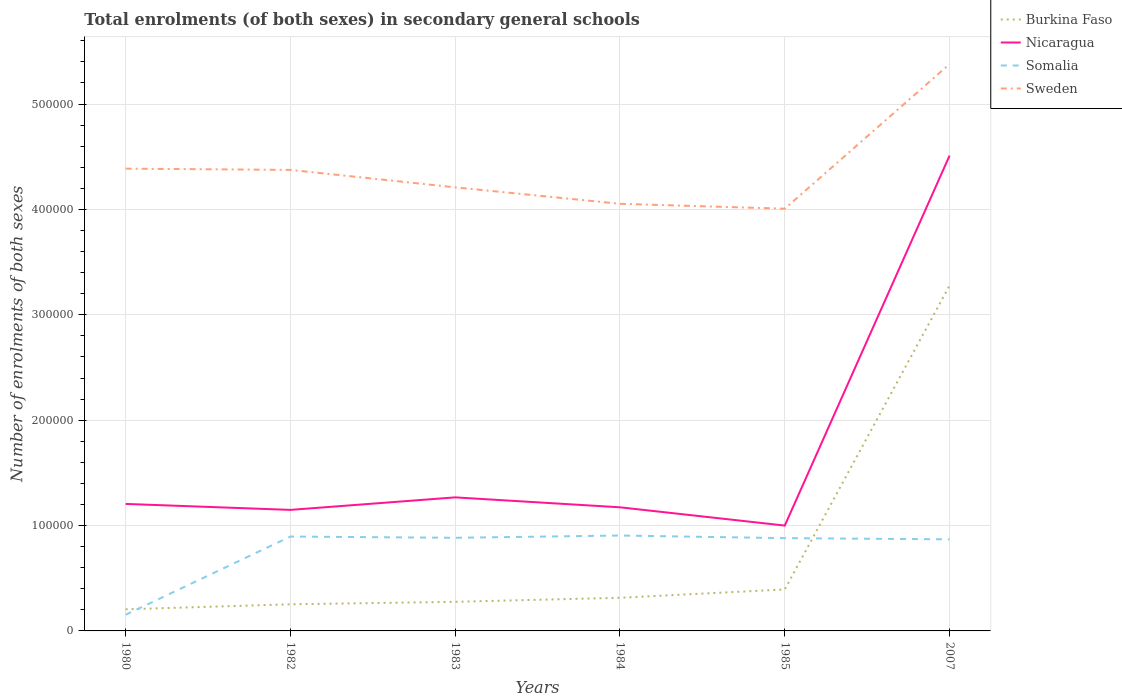Across all years, what is the maximum number of enrolments in secondary schools in Somalia?
Give a very brief answer. 1.53e+04. In which year was the number of enrolments in secondary schools in Nicaragua maximum?
Your answer should be compact. 1985. What is the total number of enrolments in secondary schools in Sweden in the graph?
Ensure brevity in your answer.  1.65e+04. What is the difference between the highest and the second highest number of enrolments in secondary schools in Burkina Faso?
Offer a terse response. 3.07e+05. What is the difference between the highest and the lowest number of enrolments in secondary schools in Sweden?
Keep it short and to the point. 1. Is the number of enrolments in secondary schools in Somalia strictly greater than the number of enrolments in secondary schools in Burkina Faso over the years?
Offer a very short reply. No. What is the difference between two consecutive major ticks on the Y-axis?
Your response must be concise. 1.00e+05. Does the graph contain any zero values?
Your answer should be compact. No. Does the graph contain grids?
Your answer should be compact. Yes. How many legend labels are there?
Ensure brevity in your answer.  4. How are the legend labels stacked?
Ensure brevity in your answer.  Vertical. What is the title of the graph?
Ensure brevity in your answer.  Total enrolments (of both sexes) in secondary general schools. What is the label or title of the Y-axis?
Your response must be concise. Number of enrolments of both sexes. What is the Number of enrolments of both sexes in Burkina Faso in 1980?
Keep it short and to the point. 2.05e+04. What is the Number of enrolments of both sexes of Nicaragua in 1980?
Keep it short and to the point. 1.21e+05. What is the Number of enrolments of both sexes in Somalia in 1980?
Ensure brevity in your answer.  1.53e+04. What is the Number of enrolments of both sexes in Sweden in 1980?
Provide a succinct answer. 4.39e+05. What is the Number of enrolments of both sexes of Burkina Faso in 1982?
Offer a terse response. 2.53e+04. What is the Number of enrolments of both sexes of Nicaragua in 1982?
Give a very brief answer. 1.15e+05. What is the Number of enrolments of both sexes of Somalia in 1982?
Offer a terse response. 8.96e+04. What is the Number of enrolments of both sexes of Sweden in 1982?
Ensure brevity in your answer.  4.38e+05. What is the Number of enrolments of both sexes of Burkina Faso in 1983?
Offer a very short reply. 2.76e+04. What is the Number of enrolments of both sexes of Nicaragua in 1983?
Ensure brevity in your answer.  1.27e+05. What is the Number of enrolments of both sexes in Somalia in 1983?
Offer a terse response. 8.84e+04. What is the Number of enrolments of both sexes in Sweden in 1983?
Your answer should be very brief. 4.21e+05. What is the Number of enrolments of both sexes of Burkina Faso in 1984?
Keep it short and to the point. 3.15e+04. What is the Number of enrolments of both sexes of Nicaragua in 1984?
Offer a very short reply. 1.17e+05. What is the Number of enrolments of both sexes in Somalia in 1984?
Your response must be concise. 9.05e+04. What is the Number of enrolments of both sexes in Sweden in 1984?
Offer a very short reply. 4.05e+05. What is the Number of enrolments of both sexes in Burkina Faso in 1985?
Offer a terse response. 3.94e+04. What is the Number of enrolments of both sexes of Nicaragua in 1985?
Your answer should be very brief. 1.00e+05. What is the Number of enrolments of both sexes of Somalia in 1985?
Your answer should be very brief. 8.80e+04. What is the Number of enrolments of both sexes of Sweden in 1985?
Ensure brevity in your answer.  4.01e+05. What is the Number of enrolments of both sexes in Burkina Faso in 2007?
Offer a very short reply. 3.28e+05. What is the Number of enrolments of both sexes in Nicaragua in 2007?
Provide a succinct answer. 4.51e+05. What is the Number of enrolments of both sexes in Somalia in 2007?
Keep it short and to the point. 8.69e+04. What is the Number of enrolments of both sexes of Sweden in 2007?
Give a very brief answer. 5.38e+05. Across all years, what is the maximum Number of enrolments of both sexes of Burkina Faso?
Provide a short and direct response. 3.28e+05. Across all years, what is the maximum Number of enrolments of both sexes of Nicaragua?
Offer a terse response. 4.51e+05. Across all years, what is the maximum Number of enrolments of both sexes in Somalia?
Make the answer very short. 9.05e+04. Across all years, what is the maximum Number of enrolments of both sexes of Sweden?
Provide a succinct answer. 5.38e+05. Across all years, what is the minimum Number of enrolments of both sexes in Burkina Faso?
Make the answer very short. 2.05e+04. Across all years, what is the minimum Number of enrolments of both sexes of Nicaragua?
Your answer should be compact. 1.00e+05. Across all years, what is the minimum Number of enrolments of both sexes in Somalia?
Provide a short and direct response. 1.53e+04. Across all years, what is the minimum Number of enrolments of both sexes of Sweden?
Your answer should be compact. 4.01e+05. What is the total Number of enrolments of both sexes in Burkina Faso in the graph?
Make the answer very short. 4.72e+05. What is the total Number of enrolments of both sexes of Nicaragua in the graph?
Ensure brevity in your answer.  1.03e+06. What is the total Number of enrolments of both sexes of Somalia in the graph?
Make the answer very short. 4.59e+05. What is the total Number of enrolments of both sexes of Sweden in the graph?
Ensure brevity in your answer.  2.64e+06. What is the difference between the Number of enrolments of both sexes in Burkina Faso in 1980 and that in 1982?
Make the answer very short. -4744. What is the difference between the Number of enrolments of both sexes in Nicaragua in 1980 and that in 1982?
Keep it short and to the point. 5654. What is the difference between the Number of enrolments of both sexes of Somalia in 1980 and that in 1982?
Offer a very short reply. -7.42e+04. What is the difference between the Number of enrolments of both sexes of Sweden in 1980 and that in 1982?
Provide a short and direct response. 1194. What is the difference between the Number of enrolments of both sexes of Burkina Faso in 1980 and that in 1983?
Give a very brief answer. -7089. What is the difference between the Number of enrolments of both sexes in Nicaragua in 1980 and that in 1983?
Provide a succinct answer. -6216. What is the difference between the Number of enrolments of both sexes of Somalia in 1980 and that in 1983?
Give a very brief answer. -7.30e+04. What is the difference between the Number of enrolments of both sexes of Sweden in 1980 and that in 1983?
Offer a terse response. 1.77e+04. What is the difference between the Number of enrolments of both sexes in Burkina Faso in 1980 and that in 1984?
Give a very brief answer. -1.09e+04. What is the difference between the Number of enrolments of both sexes of Nicaragua in 1980 and that in 1984?
Offer a terse response. 3207. What is the difference between the Number of enrolments of both sexes of Somalia in 1980 and that in 1984?
Your response must be concise. -7.52e+04. What is the difference between the Number of enrolments of both sexes of Sweden in 1980 and that in 1984?
Your response must be concise. 3.34e+04. What is the difference between the Number of enrolments of both sexes in Burkina Faso in 1980 and that in 1985?
Provide a short and direct response. -1.88e+04. What is the difference between the Number of enrolments of both sexes in Nicaragua in 1980 and that in 1985?
Ensure brevity in your answer.  2.05e+04. What is the difference between the Number of enrolments of both sexes in Somalia in 1980 and that in 1985?
Ensure brevity in your answer.  -7.27e+04. What is the difference between the Number of enrolments of both sexes in Sweden in 1980 and that in 1985?
Provide a succinct answer. 3.80e+04. What is the difference between the Number of enrolments of both sexes of Burkina Faso in 1980 and that in 2007?
Ensure brevity in your answer.  -3.07e+05. What is the difference between the Number of enrolments of both sexes of Nicaragua in 1980 and that in 2007?
Keep it short and to the point. -3.31e+05. What is the difference between the Number of enrolments of both sexes of Somalia in 1980 and that in 2007?
Your answer should be compact. -7.16e+04. What is the difference between the Number of enrolments of both sexes in Sweden in 1980 and that in 2007?
Provide a short and direct response. -9.92e+04. What is the difference between the Number of enrolments of both sexes of Burkina Faso in 1982 and that in 1983?
Offer a very short reply. -2345. What is the difference between the Number of enrolments of both sexes of Nicaragua in 1982 and that in 1983?
Provide a succinct answer. -1.19e+04. What is the difference between the Number of enrolments of both sexes of Somalia in 1982 and that in 1983?
Your response must be concise. 1177. What is the difference between the Number of enrolments of both sexes of Sweden in 1982 and that in 1983?
Provide a short and direct response. 1.65e+04. What is the difference between the Number of enrolments of both sexes in Burkina Faso in 1982 and that in 1984?
Provide a short and direct response. -6201. What is the difference between the Number of enrolments of both sexes in Nicaragua in 1982 and that in 1984?
Your answer should be very brief. -2447. What is the difference between the Number of enrolments of both sexes of Somalia in 1982 and that in 1984?
Offer a very short reply. -977. What is the difference between the Number of enrolments of both sexes of Sweden in 1982 and that in 1984?
Your answer should be very brief. 3.22e+04. What is the difference between the Number of enrolments of both sexes of Burkina Faso in 1982 and that in 1985?
Your response must be concise. -1.41e+04. What is the difference between the Number of enrolments of both sexes in Nicaragua in 1982 and that in 1985?
Give a very brief answer. 1.49e+04. What is the difference between the Number of enrolments of both sexes in Somalia in 1982 and that in 1985?
Offer a terse response. 1519. What is the difference between the Number of enrolments of both sexes in Sweden in 1982 and that in 1985?
Your answer should be very brief. 3.68e+04. What is the difference between the Number of enrolments of both sexes of Burkina Faso in 1982 and that in 2007?
Offer a terse response. -3.03e+05. What is the difference between the Number of enrolments of both sexes in Nicaragua in 1982 and that in 2007?
Keep it short and to the point. -3.36e+05. What is the difference between the Number of enrolments of both sexes of Somalia in 1982 and that in 2007?
Ensure brevity in your answer.  2629. What is the difference between the Number of enrolments of both sexes in Sweden in 1982 and that in 2007?
Provide a short and direct response. -1.00e+05. What is the difference between the Number of enrolments of both sexes in Burkina Faso in 1983 and that in 1984?
Provide a succinct answer. -3856. What is the difference between the Number of enrolments of both sexes of Nicaragua in 1983 and that in 1984?
Your answer should be very brief. 9423. What is the difference between the Number of enrolments of both sexes of Somalia in 1983 and that in 1984?
Keep it short and to the point. -2154. What is the difference between the Number of enrolments of both sexes of Sweden in 1983 and that in 1984?
Give a very brief answer. 1.56e+04. What is the difference between the Number of enrolments of both sexes of Burkina Faso in 1983 and that in 1985?
Ensure brevity in your answer.  -1.18e+04. What is the difference between the Number of enrolments of both sexes of Nicaragua in 1983 and that in 1985?
Offer a very short reply. 2.68e+04. What is the difference between the Number of enrolments of both sexes of Somalia in 1983 and that in 1985?
Give a very brief answer. 342. What is the difference between the Number of enrolments of both sexes in Sweden in 1983 and that in 1985?
Offer a very short reply. 2.03e+04. What is the difference between the Number of enrolments of both sexes of Burkina Faso in 1983 and that in 2007?
Offer a very short reply. -3.00e+05. What is the difference between the Number of enrolments of both sexes of Nicaragua in 1983 and that in 2007?
Provide a succinct answer. -3.24e+05. What is the difference between the Number of enrolments of both sexes of Somalia in 1983 and that in 2007?
Offer a terse response. 1452. What is the difference between the Number of enrolments of both sexes of Sweden in 1983 and that in 2007?
Your response must be concise. -1.17e+05. What is the difference between the Number of enrolments of both sexes of Burkina Faso in 1984 and that in 1985?
Offer a terse response. -7895. What is the difference between the Number of enrolments of both sexes of Nicaragua in 1984 and that in 1985?
Give a very brief answer. 1.73e+04. What is the difference between the Number of enrolments of both sexes of Somalia in 1984 and that in 1985?
Your answer should be compact. 2496. What is the difference between the Number of enrolments of both sexes of Sweden in 1984 and that in 1985?
Your answer should be compact. 4644. What is the difference between the Number of enrolments of both sexes in Burkina Faso in 1984 and that in 2007?
Your answer should be compact. -2.96e+05. What is the difference between the Number of enrolments of both sexes of Nicaragua in 1984 and that in 2007?
Your answer should be compact. -3.34e+05. What is the difference between the Number of enrolments of both sexes of Somalia in 1984 and that in 2007?
Give a very brief answer. 3606. What is the difference between the Number of enrolments of both sexes in Sweden in 1984 and that in 2007?
Keep it short and to the point. -1.33e+05. What is the difference between the Number of enrolments of both sexes of Burkina Faso in 1985 and that in 2007?
Your answer should be very brief. -2.88e+05. What is the difference between the Number of enrolments of both sexes in Nicaragua in 1985 and that in 2007?
Give a very brief answer. -3.51e+05. What is the difference between the Number of enrolments of both sexes in Somalia in 1985 and that in 2007?
Your response must be concise. 1110. What is the difference between the Number of enrolments of both sexes in Sweden in 1985 and that in 2007?
Your answer should be very brief. -1.37e+05. What is the difference between the Number of enrolments of both sexes in Burkina Faso in 1980 and the Number of enrolments of both sexes in Nicaragua in 1982?
Ensure brevity in your answer.  -9.43e+04. What is the difference between the Number of enrolments of both sexes in Burkina Faso in 1980 and the Number of enrolments of both sexes in Somalia in 1982?
Provide a short and direct response. -6.90e+04. What is the difference between the Number of enrolments of both sexes in Burkina Faso in 1980 and the Number of enrolments of both sexes in Sweden in 1982?
Your answer should be very brief. -4.17e+05. What is the difference between the Number of enrolments of both sexes in Nicaragua in 1980 and the Number of enrolments of both sexes in Somalia in 1982?
Ensure brevity in your answer.  3.10e+04. What is the difference between the Number of enrolments of both sexes in Nicaragua in 1980 and the Number of enrolments of both sexes in Sweden in 1982?
Ensure brevity in your answer.  -3.17e+05. What is the difference between the Number of enrolments of both sexes of Somalia in 1980 and the Number of enrolments of both sexes of Sweden in 1982?
Give a very brief answer. -4.22e+05. What is the difference between the Number of enrolments of both sexes of Burkina Faso in 1980 and the Number of enrolments of both sexes of Nicaragua in 1983?
Offer a terse response. -1.06e+05. What is the difference between the Number of enrolments of both sexes in Burkina Faso in 1980 and the Number of enrolments of both sexes in Somalia in 1983?
Your answer should be compact. -6.79e+04. What is the difference between the Number of enrolments of both sexes of Burkina Faso in 1980 and the Number of enrolments of both sexes of Sweden in 1983?
Your response must be concise. -4.00e+05. What is the difference between the Number of enrolments of both sexes in Nicaragua in 1980 and the Number of enrolments of both sexes in Somalia in 1983?
Ensure brevity in your answer.  3.21e+04. What is the difference between the Number of enrolments of both sexes in Nicaragua in 1980 and the Number of enrolments of both sexes in Sweden in 1983?
Ensure brevity in your answer.  -3.00e+05. What is the difference between the Number of enrolments of both sexes in Somalia in 1980 and the Number of enrolments of both sexes in Sweden in 1983?
Make the answer very short. -4.06e+05. What is the difference between the Number of enrolments of both sexes of Burkina Faso in 1980 and the Number of enrolments of both sexes of Nicaragua in 1984?
Offer a very short reply. -9.68e+04. What is the difference between the Number of enrolments of both sexes in Burkina Faso in 1980 and the Number of enrolments of both sexes in Somalia in 1984?
Offer a very short reply. -7.00e+04. What is the difference between the Number of enrolments of both sexes in Burkina Faso in 1980 and the Number of enrolments of both sexes in Sweden in 1984?
Make the answer very short. -3.85e+05. What is the difference between the Number of enrolments of both sexes of Nicaragua in 1980 and the Number of enrolments of both sexes of Somalia in 1984?
Provide a succinct answer. 3.00e+04. What is the difference between the Number of enrolments of both sexes of Nicaragua in 1980 and the Number of enrolments of both sexes of Sweden in 1984?
Provide a short and direct response. -2.85e+05. What is the difference between the Number of enrolments of both sexes of Somalia in 1980 and the Number of enrolments of both sexes of Sweden in 1984?
Offer a terse response. -3.90e+05. What is the difference between the Number of enrolments of both sexes of Burkina Faso in 1980 and the Number of enrolments of both sexes of Nicaragua in 1985?
Ensure brevity in your answer.  -7.95e+04. What is the difference between the Number of enrolments of both sexes in Burkina Faso in 1980 and the Number of enrolments of both sexes in Somalia in 1985?
Provide a short and direct response. -6.75e+04. What is the difference between the Number of enrolments of both sexes in Burkina Faso in 1980 and the Number of enrolments of both sexes in Sweden in 1985?
Ensure brevity in your answer.  -3.80e+05. What is the difference between the Number of enrolments of both sexes in Nicaragua in 1980 and the Number of enrolments of both sexes in Somalia in 1985?
Give a very brief answer. 3.25e+04. What is the difference between the Number of enrolments of both sexes in Nicaragua in 1980 and the Number of enrolments of both sexes in Sweden in 1985?
Give a very brief answer. -2.80e+05. What is the difference between the Number of enrolments of both sexes in Somalia in 1980 and the Number of enrolments of both sexes in Sweden in 1985?
Provide a succinct answer. -3.85e+05. What is the difference between the Number of enrolments of both sexes of Burkina Faso in 1980 and the Number of enrolments of both sexes of Nicaragua in 2007?
Ensure brevity in your answer.  -4.31e+05. What is the difference between the Number of enrolments of both sexes in Burkina Faso in 1980 and the Number of enrolments of both sexes in Somalia in 2007?
Your answer should be very brief. -6.64e+04. What is the difference between the Number of enrolments of both sexes in Burkina Faso in 1980 and the Number of enrolments of both sexes in Sweden in 2007?
Your response must be concise. -5.17e+05. What is the difference between the Number of enrolments of both sexes in Nicaragua in 1980 and the Number of enrolments of both sexes in Somalia in 2007?
Make the answer very short. 3.36e+04. What is the difference between the Number of enrolments of both sexes in Nicaragua in 1980 and the Number of enrolments of both sexes in Sweden in 2007?
Provide a succinct answer. -4.17e+05. What is the difference between the Number of enrolments of both sexes of Somalia in 1980 and the Number of enrolments of both sexes of Sweden in 2007?
Your response must be concise. -5.23e+05. What is the difference between the Number of enrolments of both sexes of Burkina Faso in 1982 and the Number of enrolments of both sexes of Nicaragua in 1983?
Your response must be concise. -1.01e+05. What is the difference between the Number of enrolments of both sexes of Burkina Faso in 1982 and the Number of enrolments of both sexes of Somalia in 1983?
Provide a short and direct response. -6.31e+04. What is the difference between the Number of enrolments of both sexes in Burkina Faso in 1982 and the Number of enrolments of both sexes in Sweden in 1983?
Your answer should be very brief. -3.96e+05. What is the difference between the Number of enrolments of both sexes of Nicaragua in 1982 and the Number of enrolments of both sexes of Somalia in 1983?
Keep it short and to the point. 2.65e+04. What is the difference between the Number of enrolments of both sexes in Nicaragua in 1982 and the Number of enrolments of both sexes in Sweden in 1983?
Give a very brief answer. -3.06e+05. What is the difference between the Number of enrolments of both sexes of Somalia in 1982 and the Number of enrolments of both sexes of Sweden in 1983?
Provide a succinct answer. -3.31e+05. What is the difference between the Number of enrolments of both sexes in Burkina Faso in 1982 and the Number of enrolments of both sexes in Nicaragua in 1984?
Your answer should be very brief. -9.20e+04. What is the difference between the Number of enrolments of both sexes of Burkina Faso in 1982 and the Number of enrolments of both sexes of Somalia in 1984?
Make the answer very short. -6.53e+04. What is the difference between the Number of enrolments of both sexes in Burkina Faso in 1982 and the Number of enrolments of both sexes in Sweden in 1984?
Your answer should be compact. -3.80e+05. What is the difference between the Number of enrolments of both sexes in Nicaragua in 1982 and the Number of enrolments of both sexes in Somalia in 1984?
Offer a very short reply. 2.43e+04. What is the difference between the Number of enrolments of both sexes of Nicaragua in 1982 and the Number of enrolments of both sexes of Sweden in 1984?
Make the answer very short. -2.90e+05. What is the difference between the Number of enrolments of both sexes in Somalia in 1982 and the Number of enrolments of both sexes in Sweden in 1984?
Your answer should be compact. -3.16e+05. What is the difference between the Number of enrolments of both sexes of Burkina Faso in 1982 and the Number of enrolments of both sexes of Nicaragua in 1985?
Your response must be concise. -7.47e+04. What is the difference between the Number of enrolments of both sexes in Burkina Faso in 1982 and the Number of enrolments of both sexes in Somalia in 1985?
Keep it short and to the point. -6.28e+04. What is the difference between the Number of enrolments of both sexes in Burkina Faso in 1982 and the Number of enrolments of both sexes in Sweden in 1985?
Offer a very short reply. -3.75e+05. What is the difference between the Number of enrolments of both sexes of Nicaragua in 1982 and the Number of enrolments of both sexes of Somalia in 1985?
Give a very brief answer. 2.68e+04. What is the difference between the Number of enrolments of both sexes in Nicaragua in 1982 and the Number of enrolments of both sexes in Sweden in 1985?
Keep it short and to the point. -2.86e+05. What is the difference between the Number of enrolments of both sexes in Somalia in 1982 and the Number of enrolments of both sexes in Sweden in 1985?
Keep it short and to the point. -3.11e+05. What is the difference between the Number of enrolments of both sexes of Burkina Faso in 1982 and the Number of enrolments of both sexes of Nicaragua in 2007?
Give a very brief answer. -4.26e+05. What is the difference between the Number of enrolments of both sexes of Burkina Faso in 1982 and the Number of enrolments of both sexes of Somalia in 2007?
Provide a succinct answer. -6.17e+04. What is the difference between the Number of enrolments of both sexes in Burkina Faso in 1982 and the Number of enrolments of both sexes in Sweden in 2007?
Ensure brevity in your answer.  -5.13e+05. What is the difference between the Number of enrolments of both sexes of Nicaragua in 1982 and the Number of enrolments of both sexes of Somalia in 2007?
Your answer should be compact. 2.79e+04. What is the difference between the Number of enrolments of both sexes in Nicaragua in 1982 and the Number of enrolments of both sexes in Sweden in 2007?
Keep it short and to the point. -4.23e+05. What is the difference between the Number of enrolments of both sexes of Somalia in 1982 and the Number of enrolments of both sexes of Sweden in 2007?
Keep it short and to the point. -4.48e+05. What is the difference between the Number of enrolments of both sexes in Burkina Faso in 1983 and the Number of enrolments of both sexes in Nicaragua in 1984?
Give a very brief answer. -8.97e+04. What is the difference between the Number of enrolments of both sexes in Burkina Faso in 1983 and the Number of enrolments of both sexes in Somalia in 1984?
Your answer should be compact. -6.29e+04. What is the difference between the Number of enrolments of both sexes in Burkina Faso in 1983 and the Number of enrolments of both sexes in Sweden in 1984?
Give a very brief answer. -3.78e+05. What is the difference between the Number of enrolments of both sexes of Nicaragua in 1983 and the Number of enrolments of both sexes of Somalia in 1984?
Offer a terse response. 3.62e+04. What is the difference between the Number of enrolments of both sexes in Nicaragua in 1983 and the Number of enrolments of both sexes in Sweden in 1984?
Provide a succinct answer. -2.79e+05. What is the difference between the Number of enrolments of both sexes in Somalia in 1983 and the Number of enrolments of both sexes in Sweden in 1984?
Make the answer very short. -3.17e+05. What is the difference between the Number of enrolments of both sexes of Burkina Faso in 1983 and the Number of enrolments of both sexes of Nicaragua in 1985?
Your answer should be very brief. -7.24e+04. What is the difference between the Number of enrolments of both sexes of Burkina Faso in 1983 and the Number of enrolments of both sexes of Somalia in 1985?
Offer a terse response. -6.04e+04. What is the difference between the Number of enrolments of both sexes in Burkina Faso in 1983 and the Number of enrolments of both sexes in Sweden in 1985?
Make the answer very short. -3.73e+05. What is the difference between the Number of enrolments of both sexes in Nicaragua in 1983 and the Number of enrolments of both sexes in Somalia in 1985?
Give a very brief answer. 3.87e+04. What is the difference between the Number of enrolments of both sexes in Nicaragua in 1983 and the Number of enrolments of both sexes in Sweden in 1985?
Ensure brevity in your answer.  -2.74e+05. What is the difference between the Number of enrolments of both sexes of Somalia in 1983 and the Number of enrolments of both sexes of Sweden in 1985?
Offer a very short reply. -3.12e+05. What is the difference between the Number of enrolments of both sexes in Burkina Faso in 1983 and the Number of enrolments of both sexes in Nicaragua in 2007?
Offer a terse response. -4.23e+05. What is the difference between the Number of enrolments of both sexes in Burkina Faso in 1983 and the Number of enrolments of both sexes in Somalia in 2007?
Your response must be concise. -5.93e+04. What is the difference between the Number of enrolments of both sexes in Burkina Faso in 1983 and the Number of enrolments of both sexes in Sweden in 2007?
Provide a short and direct response. -5.10e+05. What is the difference between the Number of enrolments of both sexes in Nicaragua in 1983 and the Number of enrolments of both sexes in Somalia in 2007?
Your answer should be very brief. 3.98e+04. What is the difference between the Number of enrolments of both sexes of Nicaragua in 1983 and the Number of enrolments of both sexes of Sweden in 2007?
Offer a very short reply. -4.11e+05. What is the difference between the Number of enrolments of both sexes in Somalia in 1983 and the Number of enrolments of both sexes in Sweden in 2007?
Make the answer very short. -4.50e+05. What is the difference between the Number of enrolments of both sexes in Burkina Faso in 1984 and the Number of enrolments of both sexes in Nicaragua in 1985?
Offer a terse response. -6.85e+04. What is the difference between the Number of enrolments of both sexes in Burkina Faso in 1984 and the Number of enrolments of both sexes in Somalia in 1985?
Provide a short and direct response. -5.66e+04. What is the difference between the Number of enrolments of both sexes of Burkina Faso in 1984 and the Number of enrolments of both sexes of Sweden in 1985?
Offer a very short reply. -3.69e+05. What is the difference between the Number of enrolments of both sexes of Nicaragua in 1984 and the Number of enrolments of both sexes of Somalia in 1985?
Your answer should be very brief. 2.93e+04. What is the difference between the Number of enrolments of both sexes of Nicaragua in 1984 and the Number of enrolments of both sexes of Sweden in 1985?
Provide a short and direct response. -2.83e+05. What is the difference between the Number of enrolments of both sexes in Somalia in 1984 and the Number of enrolments of both sexes in Sweden in 1985?
Offer a terse response. -3.10e+05. What is the difference between the Number of enrolments of both sexes of Burkina Faso in 1984 and the Number of enrolments of both sexes of Nicaragua in 2007?
Your answer should be very brief. -4.20e+05. What is the difference between the Number of enrolments of both sexes in Burkina Faso in 1984 and the Number of enrolments of both sexes in Somalia in 2007?
Your response must be concise. -5.55e+04. What is the difference between the Number of enrolments of both sexes in Burkina Faso in 1984 and the Number of enrolments of both sexes in Sweden in 2007?
Provide a succinct answer. -5.06e+05. What is the difference between the Number of enrolments of both sexes in Nicaragua in 1984 and the Number of enrolments of both sexes in Somalia in 2007?
Your answer should be very brief. 3.04e+04. What is the difference between the Number of enrolments of both sexes of Nicaragua in 1984 and the Number of enrolments of both sexes of Sweden in 2007?
Give a very brief answer. -4.21e+05. What is the difference between the Number of enrolments of both sexes in Somalia in 1984 and the Number of enrolments of both sexes in Sweden in 2007?
Keep it short and to the point. -4.47e+05. What is the difference between the Number of enrolments of both sexes of Burkina Faso in 1985 and the Number of enrolments of both sexes of Nicaragua in 2007?
Provide a short and direct response. -4.12e+05. What is the difference between the Number of enrolments of both sexes in Burkina Faso in 1985 and the Number of enrolments of both sexes in Somalia in 2007?
Provide a succinct answer. -4.76e+04. What is the difference between the Number of enrolments of both sexes in Burkina Faso in 1985 and the Number of enrolments of both sexes in Sweden in 2007?
Offer a terse response. -4.99e+05. What is the difference between the Number of enrolments of both sexes of Nicaragua in 1985 and the Number of enrolments of both sexes of Somalia in 2007?
Your answer should be very brief. 1.31e+04. What is the difference between the Number of enrolments of both sexes of Nicaragua in 1985 and the Number of enrolments of both sexes of Sweden in 2007?
Your answer should be very brief. -4.38e+05. What is the difference between the Number of enrolments of both sexes in Somalia in 1985 and the Number of enrolments of both sexes in Sweden in 2007?
Give a very brief answer. -4.50e+05. What is the average Number of enrolments of both sexes of Burkina Faso per year?
Your response must be concise. 7.87e+04. What is the average Number of enrolments of both sexes of Nicaragua per year?
Keep it short and to the point. 1.72e+05. What is the average Number of enrolments of both sexes in Somalia per year?
Provide a succinct answer. 7.65e+04. What is the average Number of enrolments of both sexes in Sweden per year?
Your response must be concise. 4.40e+05. In the year 1980, what is the difference between the Number of enrolments of both sexes in Burkina Faso and Number of enrolments of both sexes in Nicaragua?
Offer a very short reply. -1.00e+05. In the year 1980, what is the difference between the Number of enrolments of both sexes in Burkina Faso and Number of enrolments of both sexes in Somalia?
Give a very brief answer. 5191. In the year 1980, what is the difference between the Number of enrolments of both sexes in Burkina Faso and Number of enrolments of both sexes in Sweden?
Ensure brevity in your answer.  -4.18e+05. In the year 1980, what is the difference between the Number of enrolments of both sexes of Nicaragua and Number of enrolments of both sexes of Somalia?
Keep it short and to the point. 1.05e+05. In the year 1980, what is the difference between the Number of enrolments of both sexes of Nicaragua and Number of enrolments of both sexes of Sweden?
Provide a short and direct response. -3.18e+05. In the year 1980, what is the difference between the Number of enrolments of both sexes of Somalia and Number of enrolments of both sexes of Sweden?
Your response must be concise. -4.23e+05. In the year 1982, what is the difference between the Number of enrolments of both sexes of Burkina Faso and Number of enrolments of both sexes of Nicaragua?
Your response must be concise. -8.96e+04. In the year 1982, what is the difference between the Number of enrolments of both sexes in Burkina Faso and Number of enrolments of both sexes in Somalia?
Make the answer very short. -6.43e+04. In the year 1982, what is the difference between the Number of enrolments of both sexes of Burkina Faso and Number of enrolments of both sexes of Sweden?
Keep it short and to the point. -4.12e+05. In the year 1982, what is the difference between the Number of enrolments of both sexes of Nicaragua and Number of enrolments of both sexes of Somalia?
Provide a succinct answer. 2.53e+04. In the year 1982, what is the difference between the Number of enrolments of both sexes of Nicaragua and Number of enrolments of both sexes of Sweden?
Keep it short and to the point. -3.23e+05. In the year 1982, what is the difference between the Number of enrolments of both sexes in Somalia and Number of enrolments of both sexes in Sweden?
Give a very brief answer. -3.48e+05. In the year 1983, what is the difference between the Number of enrolments of both sexes of Burkina Faso and Number of enrolments of both sexes of Nicaragua?
Ensure brevity in your answer.  -9.91e+04. In the year 1983, what is the difference between the Number of enrolments of both sexes of Burkina Faso and Number of enrolments of both sexes of Somalia?
Provide a succinct answer. -6.08e+04. In the year 1983, what is the difference between the Number of enrolments of both sexes of Burkina Faso and Number of enrolments of both sexes of Sweden?
Your answer should be very brief. -3.93e+05. In the year 1983, what is the difference between the Number of enrolments of both sexes in Nicaragua and Number of enrolments of both sexes in Somalia?
Offer a very short reply. 3.84e+04. In the year 1983, what is the difference between the Number of enrolments of both sexes of Nicaragua and Number of enrolments of both sexes of Sweden?
Offer a terse response. -2.94e+05. In the year 1983, what is the difference between the Number of enrolments of both sexes of Somalia and Number of enrolments of both sexes of Sweden?
Offer a terse response. -3.33e+05. In the year 1984, what is the difference between the Number of enrolments of both sexes of Burkina Faso and Number of enrolments of both sexes of Nicaragua?
Your response must be concise. -8.58e+04. In the year 1984, what is the difference between the Number of enrolments of both sexes of Burkina Faso and Number of enrolments of both sexes of Somalia?
Give a very brief answer. -5.91e+04. In the year 1984, what is the difference between the Number of enrolments of both sexes in Burkina Faso and Number of enrolments of both sexes in Sweden?
Offer a very short reply. -3.74e+05. In the year 1984, what is the difference between the Number of enrolments of both sexes of Nicaragua and Number of enrolments of both sexes of Somalia?
Keep it short and to the point. 2.68e+04. In the year 1984, what is the difference between the Number of enrolments of both sexes of Nicaragua and Number of enrolments of both sexes of Sweden?
Your response must be concise. -2.88e+05. In the year 1984, what is the difference between the Number of enrolments of both sexes of Somalia and Number of enrolments of both sexes of Sweden?
Your response must be concise. -3.15e+05. In the year 1985, what is the difference between the Number of enrolments of both sexes in Burkina Faso and Number of enrolments of both sexes in Nicaragua?
Ensure brevity in your answer.  -6.06e+04. In the year 1985, what is the difference between the Number of enrolments of both sexes of Burkina Faso and Number of enrolments of both sexes of Somalia?
Ensure brevity in your answer.  -4.87e+04. In the year 1985, what is the difference between the Number of enrolments of both sexes of Burkina Faso and Number of enrolments of both sexes of Sweden?
Provide a short and direct response. -3.61e+05. In the year 1985, what is the difference between the Number of enrolments of both sexes of Nicaragua and Number of enrolments of both sexes of Somalia?
Keep it short and to the point. 1.19e+04. In the year 1985, what is the difference between the Number of enrolments of both sexes of Nicaragua and Number of enrolments of both sexes of Sweden?
Your answer should be compact. -3.01e+05. In the year 1985, what is the difference between the Number of enrolments of both sexes in Somalia and Number of enrolments of both sexes in Sweden?
Provide a short and direct response. -3.13e+05. In the year 2007, what is the difference between the Number of enrolments of both sexes of Burkina Faso and Number of enrolments of both sexes of Nicaragua?
Your answer should be very brief. -1.23e+05. In the year 2007, what is the difference between the Number of enrolments of both sexes of Burkina Faso and Number of enrolments of both sexes of Somalia?
Make the answer very short. 2.41e+05. In the year 2007, what is the difference between the Number of enrolments of both sexes in Burkina Faso and Number of enrolments of both sexes in Sweden?
Make the answer very short. -2.10e+05. In the year 2007, what is the difference between the Number of enrolments of both sexes of Nicaragua and Number of enrolments of both sexes of Somalia?
Your response must be concise. 3.64e+05. In the year 2007, what is the difference between the Number of enrolments of both sexes of Nicaragua and Number of enrolments of both sexes of Sweden?
Keep it short and to the point. -8.68e+04. In the year 2007, what is the difference between the Number of enrolments of both sexes of Somalia and Number of enrolments of both sexes of Sweden?
Offer a very short reply. -4.51e+05. What is the ratio of the Number of enrolments of both sexes in Burkina Faso in 1980 to that in 1982?
Your response must be concise. 0.81. What is the ratio of the Number of enrolments of both sexes in Nicaragua in 1980 to that in 1982?
Your answer should be very brief. 1.05. What is the ratio of the Number of enrolments of both sexes of Somalia in 1980 to that in 1982?
Offer a terse response. 0.17. What is the ratio of the Number of enrolments of both sexes of Sweden in 1980 to that in 1982?
Give a very brief answer. 1. What is the ratio of the Number of enrolments of both sexes of Burkina Faso in 1980 to that in 1983?
Offer a very short reply. 0.74. What is the ratio of the Number of enrolments of both sexes of Nicaragua in 1980 to that in 1983?
Provide a short and direct response. 0.95. What is the ratio of the Number of enrolments of both sexes of Somalia in 1980 to that in 1983?
Offer a very short reply. 0.17. What is the ratio of the Number of enrolments of both sexes in Sweden in 1980 to that in 1983?
Provide a succinct answer. 1.04. What is the ratio of the Number of enrolments of both sexes in Burkina Faso in 1980 to that in 1984?
Offer a terse response. 0.65. What is the ratio of the Number of enrolments of both sexes in Nicaragua in 1980 to that in 1984?
Offer a terse response. 1.03. What is the ratio of the Number of enrolments of both sexes of Somalia in 1980 to that in 1984?
Make the answer very short. 0.17. What is the ratio of the Number of enrolments of both sexes of Sweden in 1980 to that in 1984?
Offer a terse response. 1.08. What is the ratio of the Number of enrolments of both sexes of Burkina Faso in 1980 to that in 1985?
Your response must be concise. 0.52. What is the ratio of the Number of enrolments of both sexes in Nicaragua in 1980 to that in 1985?
Your answer should be compact. 1.21. What is the ratio of the Number of enrolments of both sexes in Somalia in 1980 to that in 1985?
Provide a short and direct response. 0.17. What is the ratio of the Number of enrolments of both sexes of Sweden in 1980 to that in 1985?
Give a very brief answer. 1.09. What is the ratio of the Number of enrolments of both sexes of Burkina Faso in 1980 to that in 2007?
Your answer should be compact. 0.06. What is the ratio of the Number of enrolments of both sexes of Nicaragua in 1980 to that in 2007?
Give a very brief answer. 0.27. What is the ratio of the Number of enrolments of both sexes in Somalia in 1980 to that in 2007?
Give a very brief answer. 0.18. What is the ratio of the Number of enrolments of both sexes of Sweden in 1980 to that in 2007?
Provide a succinct answer. 0.82. What is the ratio of the Number of enrolments of both sexes in Burkina Faso in 1982 to that in 1983?
Provide a short and direct response. 0.92. What is the ratio of the Number of enrolments of both sexes of Nicaragua in 1982 to that in 1983?
Keep it short and to the point. 0.91. What is the ratio of the Number of enrolments of both sexes in Somalia in 1982 to that in 1983?
Make the answer very short. 1.01. What is the ratio of the Number of enrolments of both sexes in Sweden in 1982 to that in 1983?
Your answer should be very brief. 1.04. What is the ratio of the Number of enrolments of both sexes in Burkina Faso in 1982 to that in 1984?
Provide a short and direct response. 0.8. What is the ratio of the Number of enrolments of both sexes of Nicaragua in 1982 to that in 1984?
Give a very brief answer. 0.98. What is the ratio of the Number of enrolments of both sexes in Somalia in 1982 to that in 1984?
Your answer should be very brief. 0.99. What is the ratio of the Number of enrolments of both sexes of Sweden in 1982 to that in 1984?
Offer a terse response. 1.08. What is the ratio of the Number of enrolments of both sexes of Burkina Faso in 1982 to that in 1985?
Make the answer very short. 0.64. What is the ratio of the Number of enrolments of both sexes in Nicaragua in 1982 to that in 1985?
Offer a very short reply. 1.15. What is the ratio of the Number of enrolments of both sexes in Somalia in 1982 to that in 1985?
Make the answer very short. 1.02. What is the ratio of the Number of enrolments of both sexes in Sweden in 1982 to that in 1985?
Offer a terse response. 1.09. What is the ratio of the Number of enrolments of both sexes of Burkina Faso in 1982 to that in 2007?
Your answer should be compact. 0.08. What is the ratio of the Number of enrolments of both sexes in Nicaragua in 1982 to that in 2007?
Keep it short and to the point. 0.25. What is the ratio of the Number of enrolments of both sexes in Somalia in 1982 to that in 2007?
Provide a short and direct response. 1.03. What is the ratio of the Number of enrolments of both sexes of Sweden in 1982 to that in 2007?
Provide a short and direct response. 0.81. What is the ratio of the Number of enrolments of both sexes of Burkina Faso in 1983 to that in 1984?
Your answer should be compact. 0.88. What is the ratio of the Number of enrolments of both sexes in Nicaragua in 1983 to that in 1984?
Your answer should be compact. 1.08. What is the ratio of the Number of enrolments of both sexes in Somalia in 1983 to that in 1984?
Provide a short and direct response. 0.98. What is the ratio of the Number of enrolments of both sexes in Sweden in 1983 to that in 1984?
Your answer should be compact. 1.04. What is the ratio of the Number of enrolments of both sexes in Burkina Faso in 1983 to that in 1985?
Ensure brevity in your answer.  0.7. What is the ratio of the Number of enrolments of both sexes of Nicaragua in 1983 to that in 1985?
Give a very brief answer. 1.27. What is the ratio of the Number of enrolments of both sexes in Somalia in 1983 to that in 1985?
Offer a very short reply. 1. What is the ratio of the Number of enrolments of both sexes in Sweden in 1983 to that in 1985?
Keep it short and to the point. 1.05. What is the ratio of the Number of enrolments of both sexes of Burkina Faso in 1983 to that in 2007?
Provide a succinct answer. 0.08. What is the ratio of the Number of enrolments of both sexes of Nicaragua in 1983 to that in 2007?
Keep it short and to the point. 0.28. What is the ratio of the Number of enrolments of both sexes in Somalia in 1983 to that in 2007?
Offer a very short reply. 1.02. What is the ratio of the Number of enrolments of both sexes in Sweden in 1983 to that in 2007?
Make the answer very short. 0.78. What is the ratio of the Number of enrolments of both sexes in Burkina Faso in 1984 to that in 1985?
Your answer should be very brief. 0.8. What is the ratio of the Number of enrolments of both sexes in Nicaragua in 1984 to that in 1985?
Give a very brief answer. 1.17. What is the ratio of the Number of enrolments of both sexes of Somalia in 1984 to that in 1985?
Offer a terse response. 1.03. What is the ratio of the Number of enrolments of both sexes in Sweden in 1984 to that in 1985?
Provide a short and direct response. 1.01. What is the ratio of the Number of enrolments of both sexes of Burkina Faso in 1984 to that in 2007?
Ensure brevity in your answer.  0.1. What is the ratio of the Number of enrolments of both sexes in Nicaragua in 1984 to that in 2007?
Make the answer very short. 0.26. What is the ratio of the Number of enrolments of both sexes in Somalia in 1984 to that in 2007?
Make the answer very short. 1.04. What is the ratio of the Number of enrolments of both sexes in Sweden in 1984 to that in 2007?
Offer a terse response. 0.75. What is the ratio of the Number of enrolments of both sexes of Burkina Faso in 1985 to that in 2007?
Make the answer very short. 0.12. What is the ratio of the Number of enrolments of both sexes of Nicaragua in 1985 to that in 2007?
Your response must be concise. 0.22. What is the ratio of the Number of enrolments of both sexes of Somalia in 1985 to that in 2007?
Your answer should be compact. 1.01. What is the ratio of the Number of enrolments of both sexes in Sweden in 1985 to that in 2007?
Your answer should be very brief. 0.74. What is the difference between the highest and the second highest Number of enrolments of both sexes of Burkina Faso?
Keep it short and to the point. 2.88e+05. What is the difference between the highest and the second highest Number of enrolments of both sexes in Nicaragua?
Your answer should be very brief. 3.24e+05. What is the difference between the highest and the second highest Number of enrolments of both sexes of Somalia?
Offer a very short reply. 977. What is the difference between the highest and the second highest Number of enrolments of both sexes in Sweden?
Make the answer very short. 9.92e+04. What is the difference between the highest and the lowest Number of enrolments of both sexes of Burkina Faso?
Offer a terse response. 3.07e+05. What is the difference between the highest and the lowest Number of enrolments of both sexes of Nicaragua?
Provide a succinct answer. 3.51e+05. What is the difference between the highest and the lowest Number of enrolments of both sexes in Somalia?
Offer a terse response. 7.52e+04. What is the difference between the highest and the lowest Number of enrolments of both sexes of Sweden?
Give a very brief answer. 1.37e+05. 